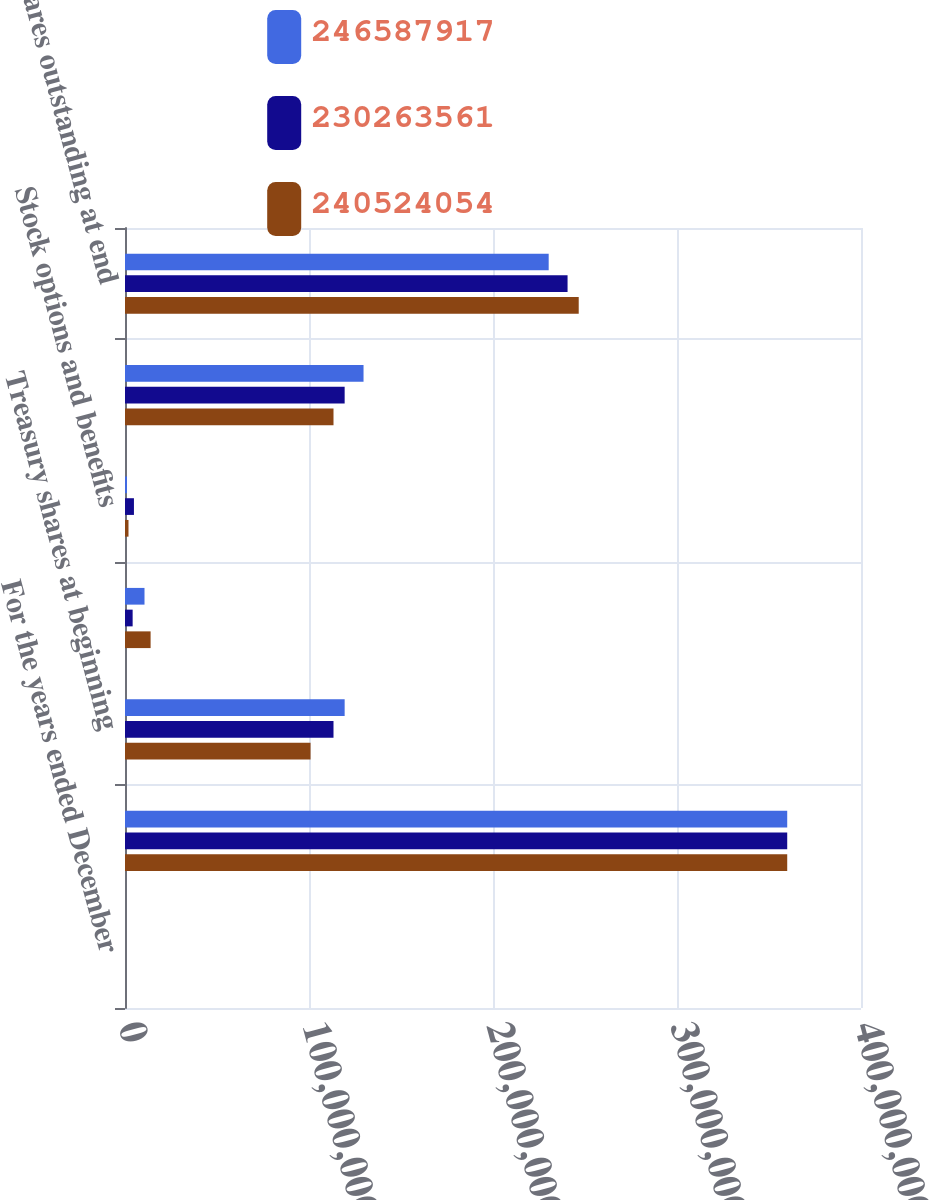Convert chart. <chart><loc_0><loc_0><loc_500><loc_500><stacked_bar_chart><ecel><fcel>For the years ended December<fcel>Shares issued<fcel>Treasury shares at beginning<fcel>Repurchase programs and<fcel>Stock options and benefits<fcel>Treasury shares at end of year<fcel>Net shares outstanding at end<nl><fcel>2.46588e+08<fcel>2006<fcel>3.59902e+08<fcel>1.19378e+08<fcel>1.06015e+07<fcel>1.09616e+06<fcel>1.29638e+08<fcel>2.30264e+08<nl><fcel>2.30264e+08<fcel>2005<fcel>3.59902e+08<fcel>1.13314e+08<fcel>4.15323e+06<fcel>4.8594e+06<fcel>1.19378e+08<fcel>2.40524e+08<nl><fcel>2.40524e+08<fcel>2004<fcel>3.59902e+08<fcel>1.00842e+08<fcel>1.39141e+07<fcel>1.89841e+06<fcel>1.13314e+08<fcel>2.46588e+08<nl></chart> 